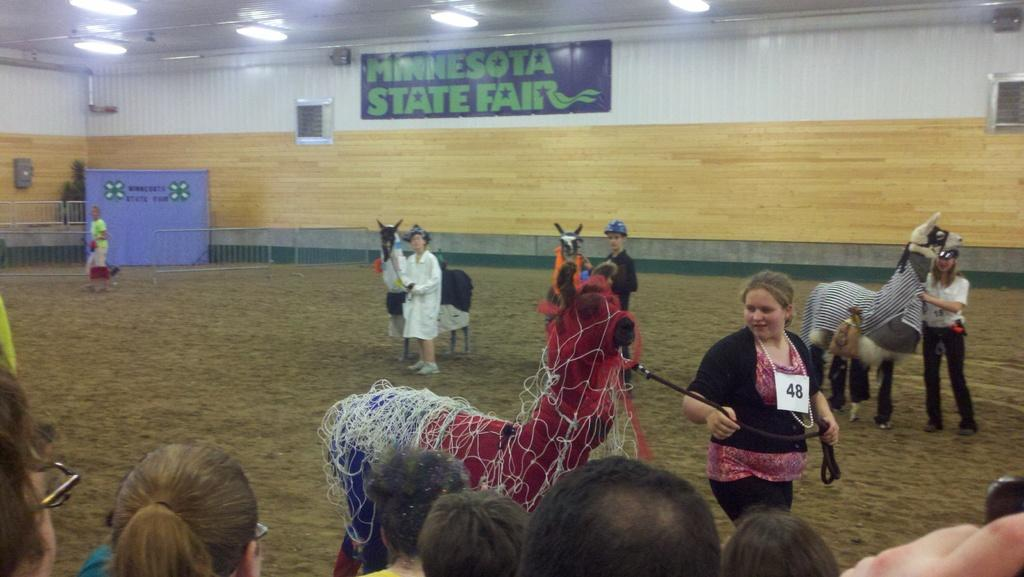What is happening in the image? There is a group of people in the image. What are some people holding in their hands? Some people are holding toy horses in their hands. What can be seen in the background of the image? There is a hoarding and lights visible in the background of the image. What type of government is depicted on the hoarding in the image? There is no government depicted on the hoarding in the image; it is a background element and does not contain any political information. 